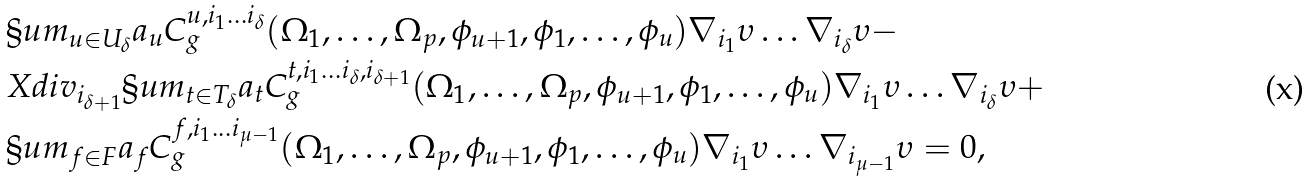<formula> <loc_0><loc_0><loc_500><loc_500>& \S u m _ { u \in U _ { \delta } } a _ { u } C ^ { u , i _ { 1 } \dots i _ { \delta } } _ { g } ( \Omega _ { 1 } , \dots , \Omega _ { p } , \phi _ { u + 1 } , \phi _ { 1 } , \dots , \phi _ { u } ) \nabla _ { i _ { 1 } } \upsilon \dots \nabla _ { i _ { \delta } } \upsilon - \\ & X d i v _ { i _ { \delta + 1 } } \S u m _ { t \in T _ { \delta } } a _ { t } C ^ { t , i _ { 1 } \dots i _ { \delta } , i _ { \delta + 1 } } _ { g } ( \Omega _ { 1 } , \dots , \Omega _ { p } , \phi _ { u + 1 } , \phi _ { 1 } , \dots , \phi _ { u } ) \nabla _ { i _ { 1 } } \upsilon \dots \nabla _ { i _ { \delta } } \upsilon + \\ & \S u m _ { f \in F } a _ { f } C ^ { f , i _ { 1 } \dots i _ { \mu - 1 } } _ { g } ( \Omega _ { 1 } , \dots , \Omega _ { p } , \phi _ { u + 1 } , \phi _ { 1 } , \dots , \phi _ { u } ) \nabla _ { i _ { 1 } } \upsilon \dots \nabla _ { i _ { \mu - 1 } } \upsilon = 0 ,</formula> 